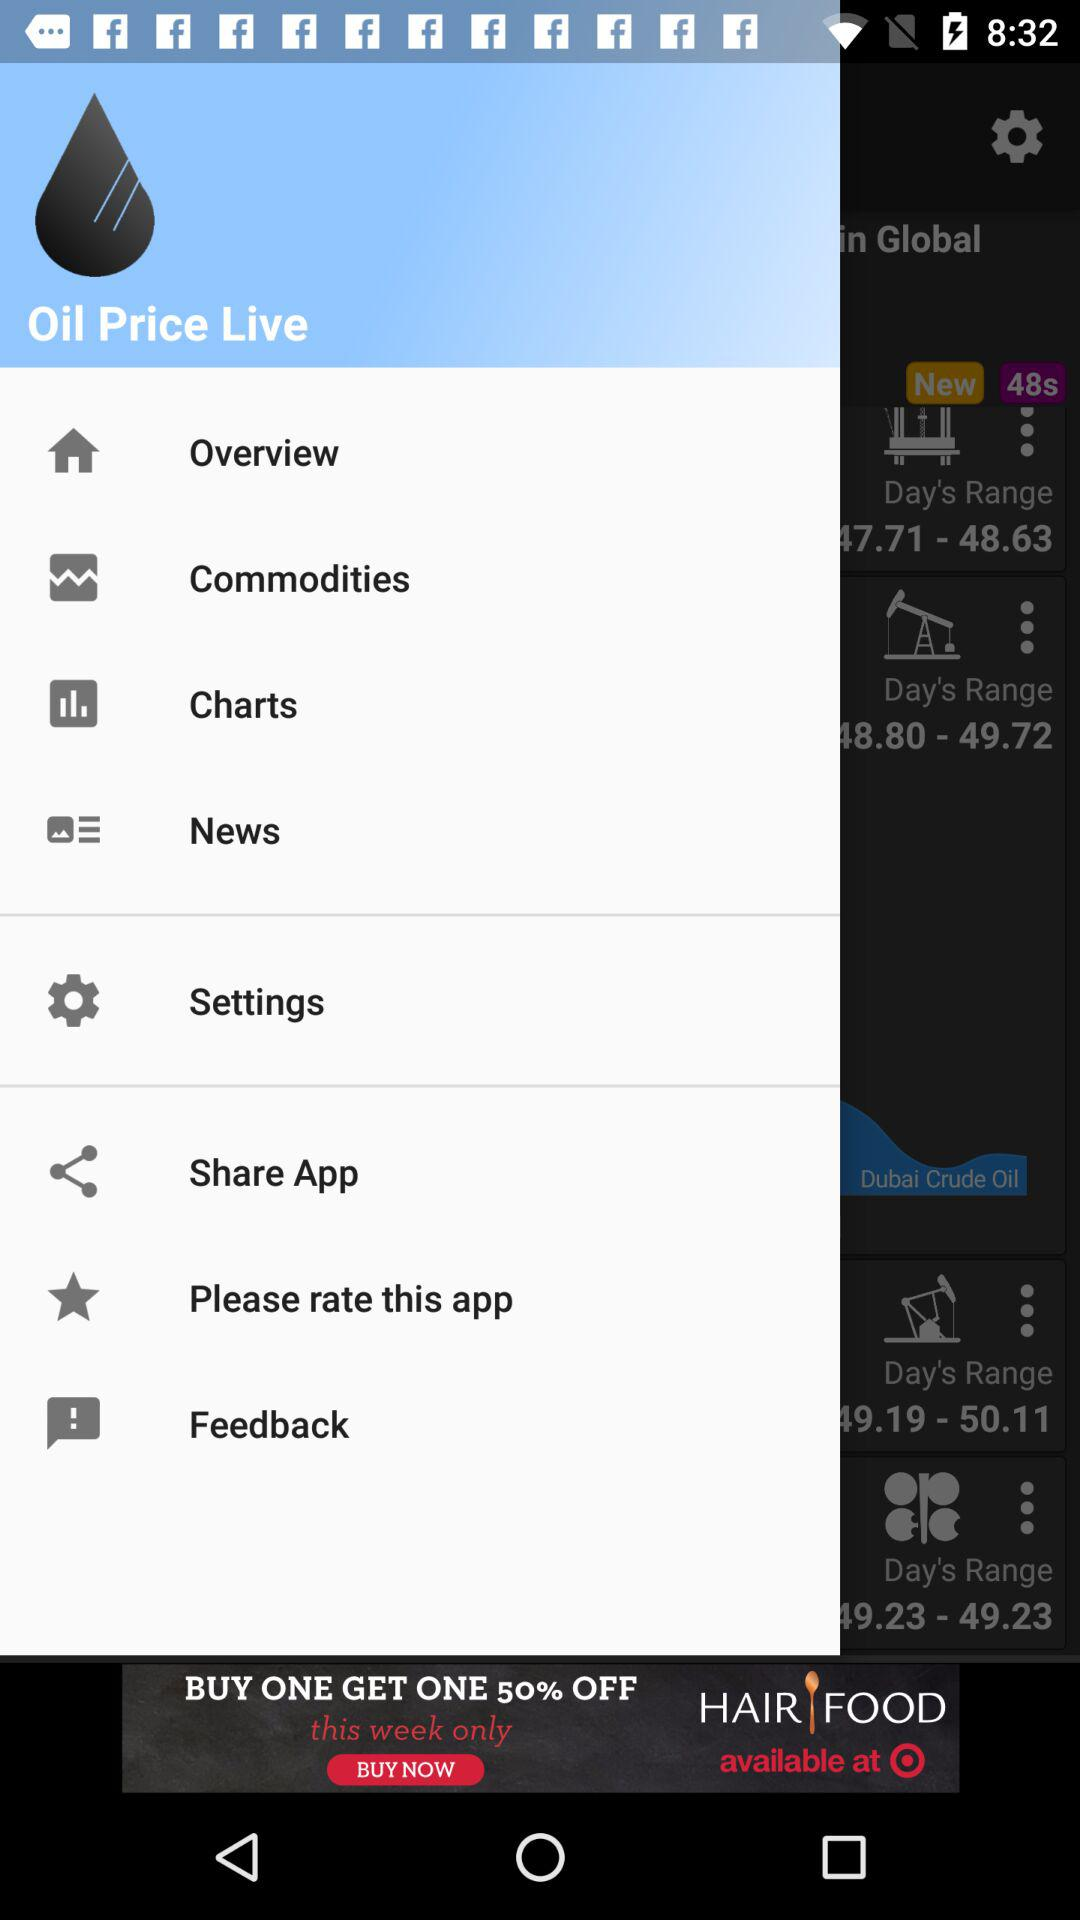What is the name of the application? The name of the application is "Oil Price Live". 